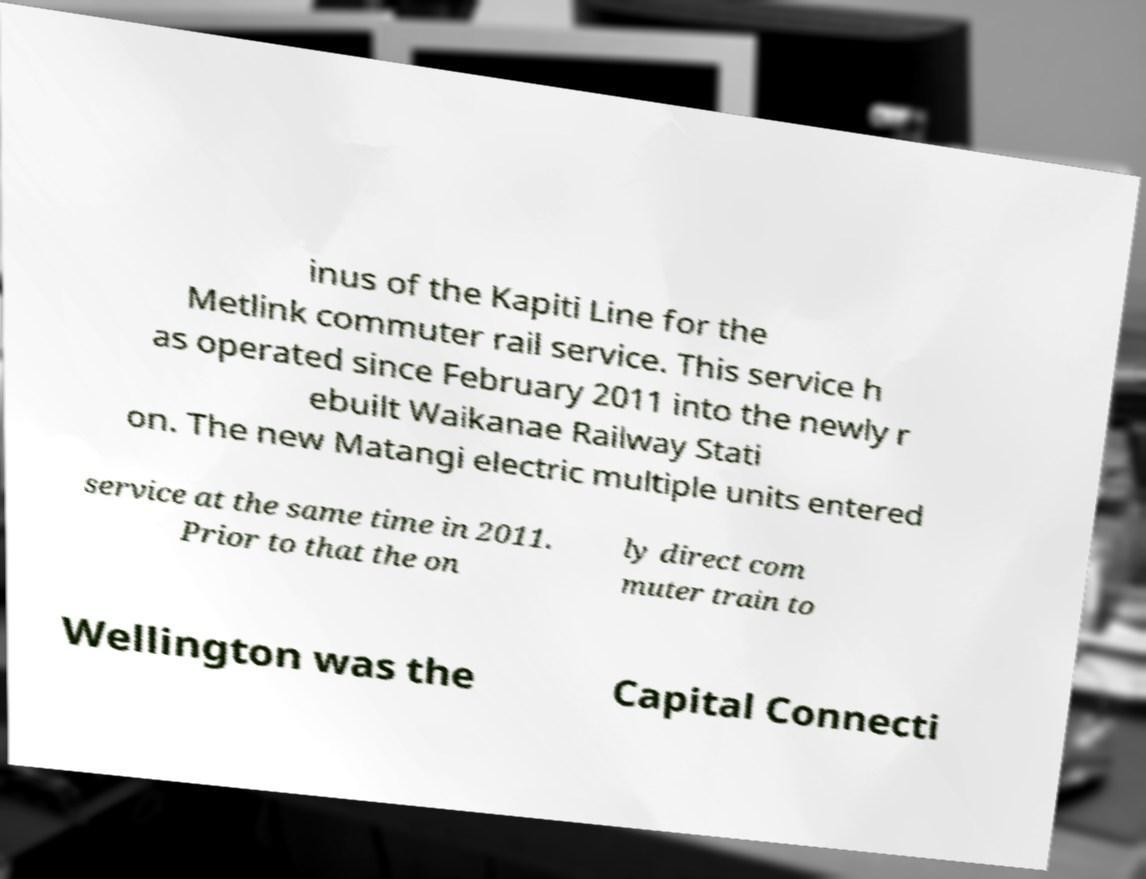Please identify and transcribe the text found in this image. inus of the Kapiti Line for the Metlink commuter rail service. This service h as operated since February 2011 into the newly r ebuilt Waikanae Railway Stati on. The new Matangi electric multiple units entered service at the same time in 2011. Prior to that the on ly direct com muter train to Wellington was the Capital Connecti 